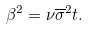<formula> <loc_0><loc_0><loc_500><loc_500>\beta ^ { 2 } = \nu \overline { \sigma } ^ { 2 } t .</formula> 